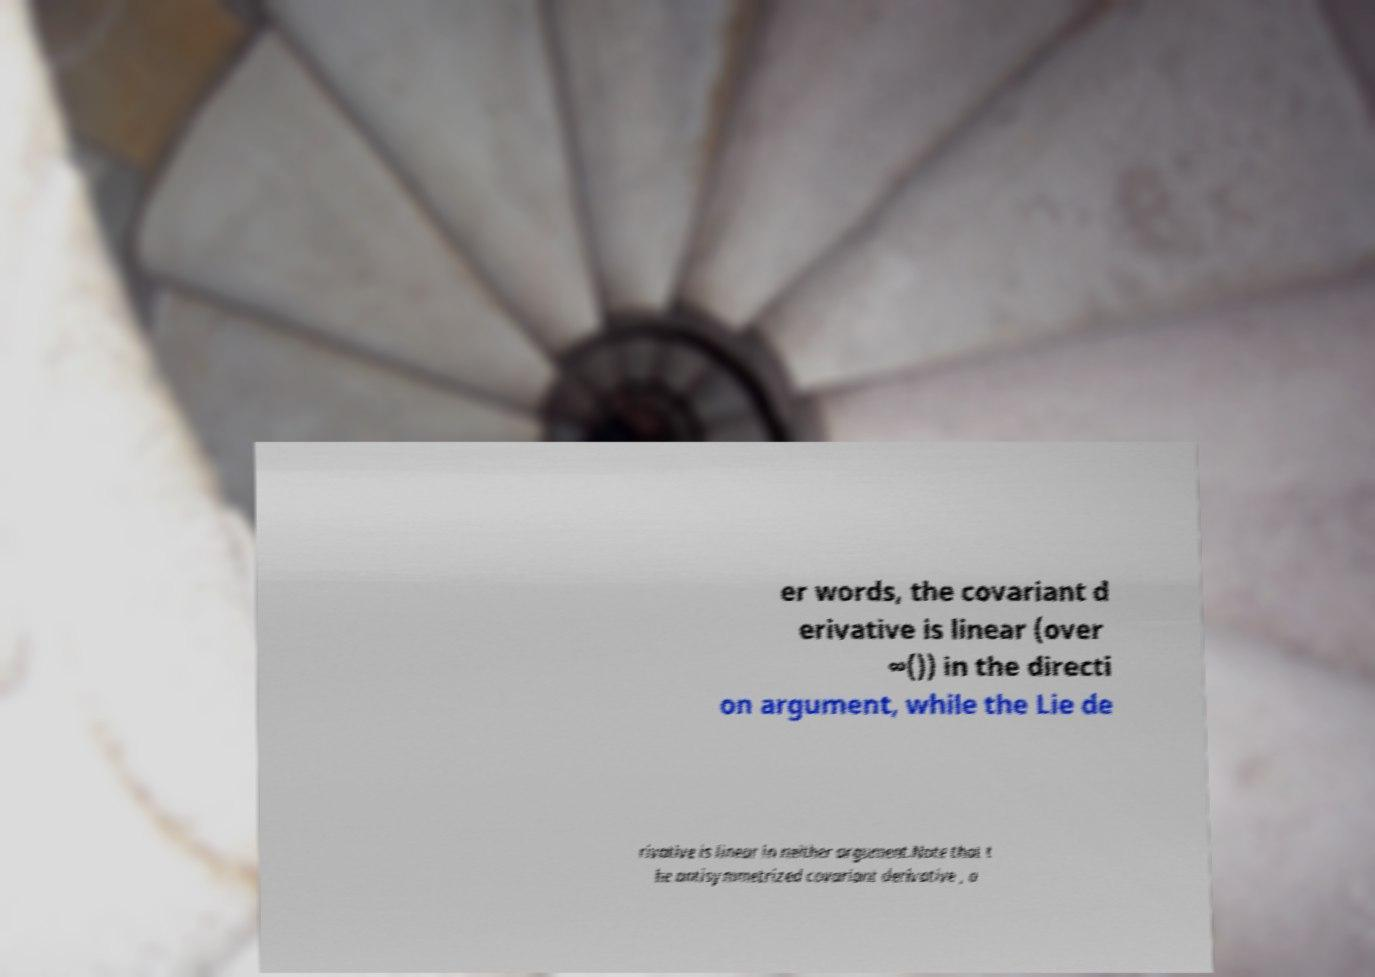What messages or text are displayed in this image? I need them in a readable, typed format. er words, the covariant d erivative is linear (over ∞()) in the directi on argument, while the Lie de rivative is linear in neither argument.Note that t he antisymmetrized covariant derivative , a 